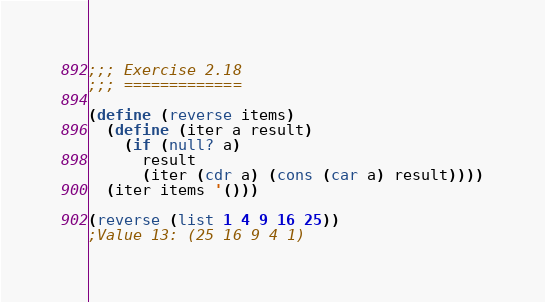Convert code to text. <code><loc_0><loc_0><loc_500><loc_500><_Scheme_>;;; Exercise 2.18
;;; =============

(define (reverse items)
  (define (iter a result)
    (if (null? a)
      result
      (iter (cdr a) (cons (car a) result))))
  (iter items '()))

(reverse (list 1 4 9 16 25))
;Value 13: (25 16 9 4 1)

</code> 